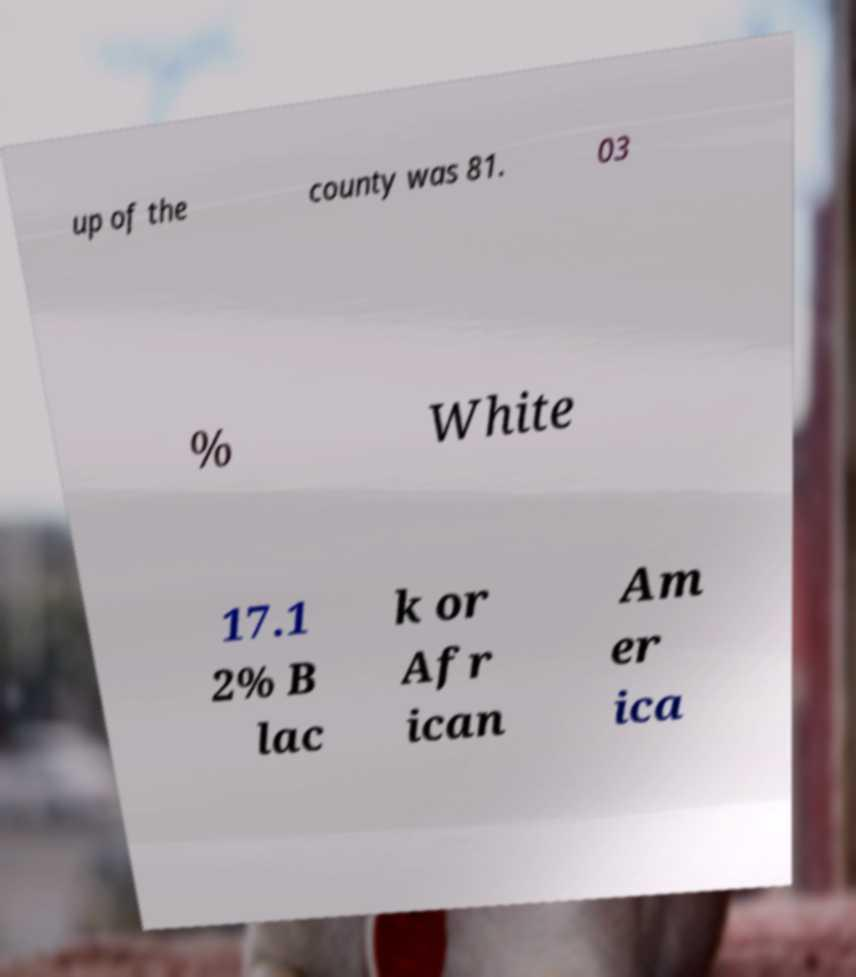Can you accurately transcribe the text from the provided image for me? up of the county was 81. 03 % White 17.1 2% B lac k or Afr ican Am er ica 